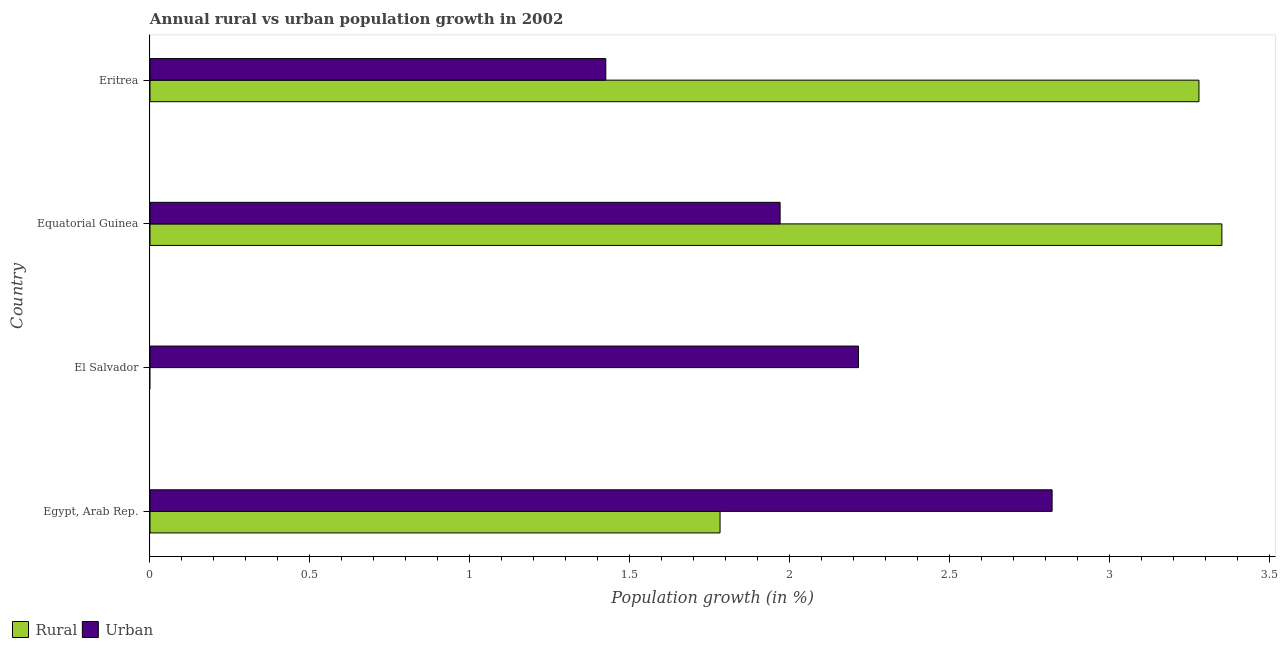How many different coloured bars are there?
Ensure brevity in your answer.  2. Are the number of bars on each tick of the Y-axis equal?
Ensure brevity in your answer.  No. How many bars are there on the 2nd tick from the top?
Provide a succinct answer. 2. How many bars are there on the 4th tick from the bottom?
Offer a terse response. 2. What is the label of the 2nd group of bars from the top?
Give a very brief answer. Equatorial Guinea. In how many cases, is the number of bars for a given country not equal to the number of legend labels?
Ensure brevity in your answer.  1. What is the urban population growth in El Salvador?
Your answer should be very brief. 2.22. Across all countries, what is the maximum urban population growth?
Offer a terse response. 2.82. Across all countries, what is the minimum urban population growth?
Offer a very short reply. 1.43. In which country was the urban population growth maximum?
Give a very brief answer. Egypt, Arab Rep. What is the total urban population growth in the graph?
Your answer should be compact. 8.43. What is the difference between the urban population growth in Equatorial Guinea and that in Eritrea?
Your response must be concise. 0.55. What is the difference between the urban population growth in Equatorial Guinea and the rural population growth in Egypt, Arab Rep.?
Give a very brief answer. 0.19. What is the average urban population growth per country?
Make the answer very short. 2.11. What is the difference between the rural population growth and urban population growth in Egypt, Arab Rep.?
Provide a succinct answer. -1.04. In how many countries, is the urban population growth greater than 2.4 %?
Make the answer very short. 1. Is the urban population growth in El Salvador less than that in Eritrea?
Offer a terse response. No. What is the difference between the highest and the second highest rural population growth?
Your response must be concise. 0.07. What is the difference between the highest and the lowest rural population growth?
Your answer should be very brief. 3.35. Are all the bars in the graph horizontal?
Keep it short and to the point. Yes. What is the difference between two consecutive major ticks on the X-axis?
Make the answer very short. 0.5. Are the values on the major ticks of X-axis written in scientific E-notation?
Your answer should be very brief. No. Does the graph contain grids?
Provide a short and direct response. No. What is the title of the graph?
Ensure brevity in your answer.  Annual rural vs urban population growth in 2002. What is the label or title of the X-axis?
Give a very brief answer. Population growth (in %). What is the label or title of the Y-axis?
Offer a terse response. Country. What is the Population growth (in %) in Rural in Egypt, Arab Rep.?
Your answer should be very brief. 1.78. What is the Population growth (in %) of Urban  in Egypt, Arab Rep.?
Keep it short and to the point. 2.82. What is the Population growth (in %) in Urban  in El Salvador?
Your answer should be very brief. 2.22. What is the Population growth (in %) in Rural in Equatorial Guinea?
Keep it short and to the point. 3.35. What is the Population growth (in %) of Urban  in Equatorial Guinea?
Your answer should be compact. 1.97. What is the Population growth (in %) in Rural in Eritrea?
Ensure brevity in your answer.  3.28. What is the Population growth (in %) in Urban  in Eritrea?
Ensure brevity in your answer.  1.43. Across all countries, what is the maximum Population growth (in %) of Rural?
Your answer should be compact. 3.35. Across all countries, what is the maximum Population growth (in %) in Urban ?
Offer a very short reply. 2.82. Across all countries, what is the minimum Population growth (in %) of Urban ?
Offer a very short reply. 1.43. What is the total Population growth (in %) of Rural in the graph?
Make the answer very short. 8.41. What is the total Population growth (in %) of Urban  in the graph?
Offer a very short reply. 8.43. What is the difference between the Population growth (in %) of Urban  in Egypt, Arab Rep. and that in El Salvador?
Your response must be concise. 0.61. What is the difference between the Population growth (in %) in Rural in Egypt, Arab Rep. and that in Equatorial Guinea?
Your response must be concise. -1.57. What is the difference between the Population growth (in %) in Urban  in Egypt, Arab Rep. and that in Equatorial Guinea?
Offer a terse response. 0.85. What is the difference between the Population growth (in %) of Rural in Egypt, Arab Rep. and that in Eritrea?
Provide a short and direct response. -1.5. What is the difference between the Population growth (in %) of Urban  in Egypt, Arab Rep. and that in Eritrea?
Give a very brief answer. 1.4. What is the difference between the Population growth (in %) in Urban  in El Salvador and that in Equatorial Guinea?
Offer a terse response. 0.24. What is the difference between the Population growth (in %) in Urban  in El Salvador and that in Eritrea?
Keep it short and to the point. 0.79. What is the difference between the Population growth (in %) in Rural in Equatorial Guinea and that in Eritrea?
Provide a short and direct response. 0.07. What is the difference between the Population growth (in %) of Urban  in Equatorial Guinea and that in Eritrea?
Your response must be concise. 0.55. What is the difference between the Population growth (in %) of Rural in Egypt, Arab Rep. and the Population growth (in %) of Urban  in El Salvador?
Your response must be concise. -0.43. What is the difference between the Population growth (in %) in Rural in Egypt, Arab Rep. and the Population growth (in %) in Urban  in Equatorial Guinea?
Make the answer very short. -0.19. What is the difference between the Population growth (in %) in Rural in Egypt, Arab Rep. and the Population growth (in %) in Urban  in Eritrea?
Your answer should be compact. 0.36. What is the difference between the Population growth (in %) in Rural in Equatorial Guinea and the Population growth (in %) in Urban  in Eritrea?
Offer a terse response. 1.93. What is the average Population growth (in %) of Rural per country?
Make the answer very short. 2.1. What is the average Population growth (in %) in Urban  per country?
Provide a short and direct response. 2.11. What is the difference between the Population growth (in %) in Rural and Population growth (in %) in Urban  in Egypt, Arab Rep.?
Your answer should be compact. -1.04. What is the difference between the Population growth (in %) of Rural and Population growth (in %) of Urban  in Equatorial Guinea?
Provide a succinct answer. 1.38. What is the difference between the Population growth (in %) of Rural and Population growth (in %) of Urban  in Eritrea?
Your response must be concise. 1.85. What is the ratio of the Population growth (in %) of Urban  in Egypt, Arab Rep. to that in El Salvador?
Make the answer very short. 1.27. What is the ratio of the Population growth (in %) of Rural in Egypt, Arab Rep. to that in Equatorial Guinea?
Keep it short and to the point. 0.53. What is the ratio of the Population growth (in %) of Urban  in Egypt, Arab Rep. to that in Equatorial Guinea?
Offer a very short reply. 1.43. What is the ratio of the Population growth (in %) in Rural in Egypt, Arab Rep. to that in Eritrea?
Your answer should be very brief. 0.54. What is the ratio of the Population growth (in %) of Urban  in Egypt, Arab Rep. to that in Eritrea?
Offer a terse response. 1.98. What is the ratio of the Population growth (in %) in Urban  in El Salvador to that in Equatorial Guinea?
Offer a terse response. 1.12. What is the ratio of the Population growth (in %) of Urban  in El Salvador to that in Eritrea?
Provide a short and direct response. 1.55. What is the ratio of the Population growth (in %) of Rural in Equatorial Guinea to that in Eritrea?
Give a very brief answer. 1.02. What is the ratio of the Population growth (in %) in Urban  in Equatorial Guinea to that in Eritrea?
Your answer should be very brief. 1.38. What is the difference between the highest and the second highest Population growth (in %) of Rural?
Offer a terse response. 0.07. What is the difference between the highest and the second highest Population growth (in %) of Urban ?
Keep it short and to the point. 0.61. What is the difference between the highest and the lowest Population growth (in %) of Rural?
Your answer should be compact. 3.35. What is the difference between the highest and the lowest Population growth (in %) in Urban ?
Make the answer very short. 1.4. 